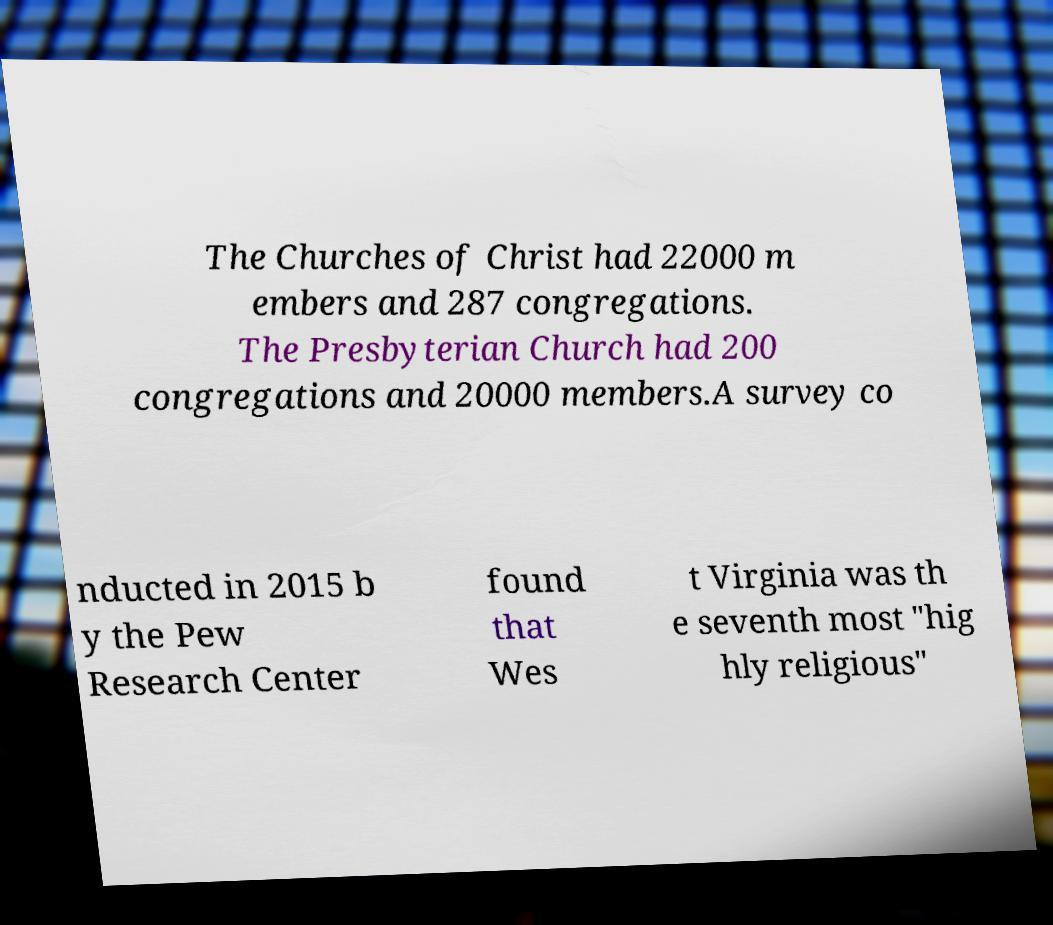Could you extract and type out the text from this image? The Churches of Christ had 22000 m embers and 287 congregations. The Presbyterian Church had 200 congregations and 20000 members.A survey co nducted in 2015 b y the Pew Research Center found that Wes t Virginia was th e seventh most "hig hly religious" 